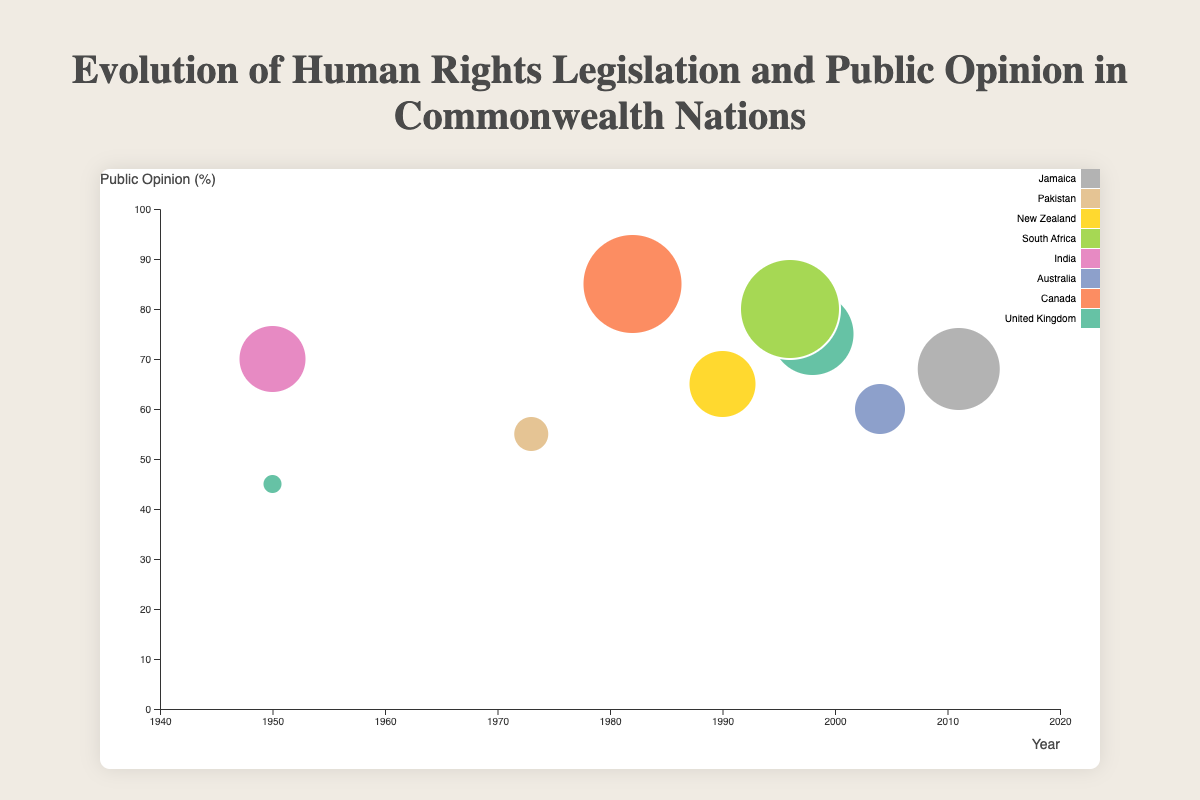What is the title of the figure? The title is prominently placed at the top of the figure. It reads "Evolution of Human Rights Legislation and Public Opinion in Commonwealth Nations."
Answer: Evolution of Human Rights Legislation and Public Opinion in Commonwealth Nations Which country had the highest score? By examining the size of the bubbles, Canada's bubble is the largest, indicating the highest score.
Answer: Canada Which legislation corresponds to the greatest public opinion percentage and in which country? The bubble for Canada has the highest value on the y-axis, which represents public opinion at 85%. The corresponding legislation is the Canadian Charter of Rights and Freedoms.
Answer: Canadian Charter of Rights and Freedoms, Canada What is the relationship between the score and the public opinion for the United Kingdom in 1998? The figure shows a bubble for the United Kingdom in 1998 with a score of 4.5 and a public opinion of 75%, indicating a positive relationship between the score and public opinion.
Answer: Positive relationship How many unique pieces of legislation are represented in the figure? Each bubble represents a unique piece of legislation. Counting the distinct entries, there are 9 unique pieces of legislation listed.
Answer: 9 Which country's legislation in 2011 observed what level of public opinion? The bubble in 2011 pertains to Jamaica. The public opinion percentage is noted to be 68%.
Answer: Jamaica, 68% Compare the public opinion for the legislation in India in 1950 and Pakistan in 1973. Which is higher and by how much? The y-axis values for public opinion are 70% for India (1950) and 55% for Pakistan (1973). The difference is 70 - 55 = 15%.
Answer: India, 15% What is the average score of legislations enacted in the 1950s? Only two legislations were enacted in the 1950s: United Kingdom (2.5) and India (4). Averaging these scores, (2.5 + 4) / 2 = 3.25.
Answer: 3.25 Which country had a change in public opinion related to human rights legislation between 1950 and 1998, and what was the change? The United Kingdom has data points for both years. Public opinion in 1950 was 45%, and in 1998 it was 75%, indicating an increase of 75 - 45 = 30%.
Answer: United Kingdom, increase of 30% Compare the legislation scores and public opinions for Jamaica in 2011 and Australia in 2004. Which has a higher combined value of score and public opinion? Adding the scores and public opinion percentages:
- Jamaica (2011): 4.5 + 68 = 72.5
- Australia (2004): 3.5 + 60 = 63.5
Jamaica has the higher combined value.
Answer: Jamaica, 72.5 